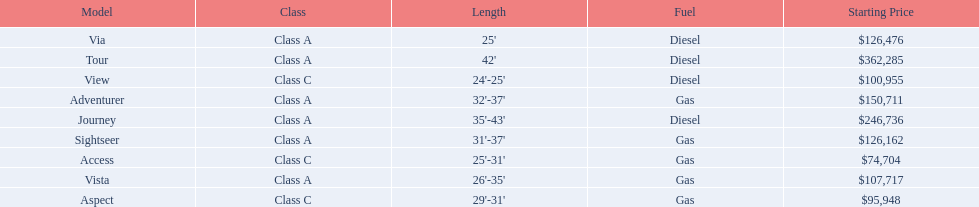What is the price of bot the via and tour models combined? $488,761. 